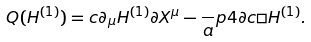<formula> <loc_0><loc_0><loc_500><loc_500>Q ( H ^ { ( 1 ) } ) = c \partial _ { \mu } H ^ { ( 1 ) } \partial X ^ { \mu } - \frac { \ } { a } p 4 \partial c \Box H ^ { ( 1 ) } .</formula> 